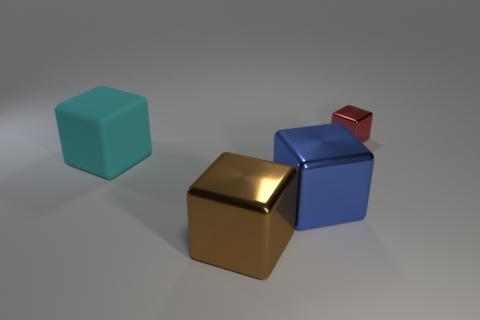What is the shape of the metallic thing in front of the blue shiny cube?
Offer a very short reply. Cube. How many big yellow cubes are there?
Provide a succinct answer. 0. Are the small red cube and the big brown cube made of the same material?
Provide a succinct answer. Yes. Are there more large cyan cubes in front of the red shiny thing than big blue rubber blocks?
Provide a short and direct response. Yes. What number of objects are either big yellow metallic things or things that are behind the blue shiny block?
Provide a succinct answer. 2. Is the number of objects that are on the right side of the red metallic object greater than the number of small shiny blocks on the right side of the brown block?
Provide a succinct answer. No. There is a big thing left of the brown metal block on the left side of the large metal object that is right of the big brown shiny cube; what is it made of?
Offer a terse response. Rubber. What shape is the tiny red object that is made of the same material as the large brown cube?
Your answer should be compact. Cube. There is a metallic thing that is behind the big cyan rubber cube; is there a red object that is behind it?
Provide a short and direct response. No. What is the size of the brown metallic object?
Offer a terse response. Large. 